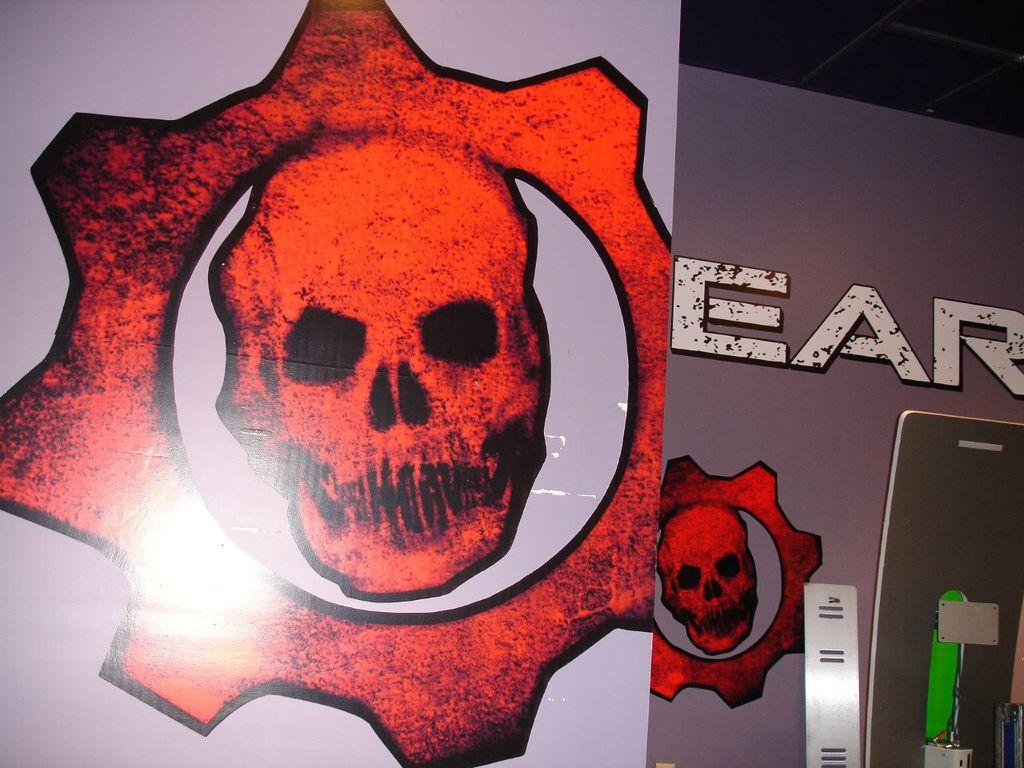What is hanging in the image? There is a banner in the image. What can be seen on the banner? The banner has danger symbols on it and text. What else is visible in the image? A mobile is visible in the image. What is located beside the banner? There are objects beside the banner. What type of advertisement is being promoted in the image? There is no indication of an advertisement in the image, as the banner has danger symbols and text related to safety or hazards. 